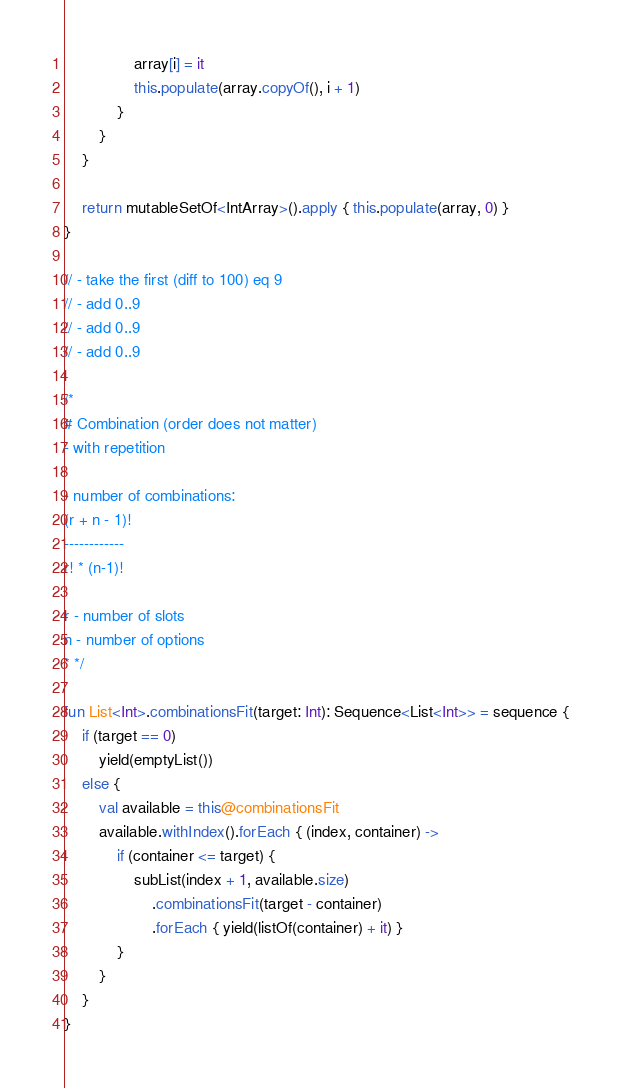<code> <loc_0><loc_0><loc_500><loc_500><_Kotlin_>                array[i] = it
                this.populate(array.copyOf(), i + 1)
            }
        }
    }

    return mutableSetOf<IntArray>().apply { this.populate(array, 0) }
}

// - take the first (diff to 100) eq 9
// - add 0..9
// - add 0..9
// - add 0..9

/*
# Combination (order does not matter)
- with repetition

- number of combinations:
(r + n - 1)!
------------
r! * (n-1)!

r - number of slots
n - number of options
* */

fun List<Int>.combinationsFit(target: Int): Sequence<List<Int>> = sequence {
    if (target == 0)
        yield(emptyList())
    else {
        val available = this@combinationsFit
        available.withIndex().forEach { (index, container) ->
            if (container <= target) {
                subList(index + 1, available.size)
                    .combinationsFit(target - container)
                    .forEach { yield(listOf(container) + it) }
            }
        }
    }
}</code> 